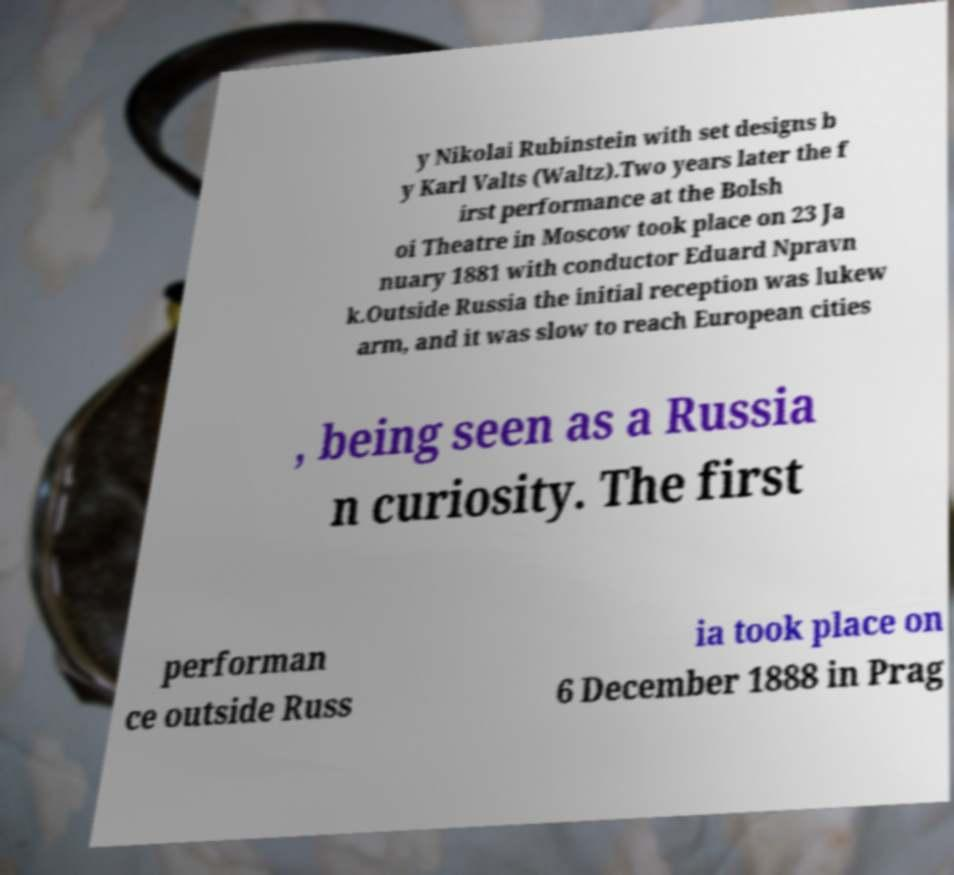Could you assist in decoding the text presented in this image and type it out clearly? y Nikolai Rubinstein with set designs b y Karl Valts (Waltz).Two years later the f irst performance at the Bolsh oi Theatre in Moscow took place on 23 Ja nuary 1881 with conductor Eduard Npravn k.Outside Russia the initial reception was lukew arm, and it was slow to reach European cities , being seen as a Russia n curiosity. The first performan ce outside Russ ia took place on 6 December 1888 in Prag 